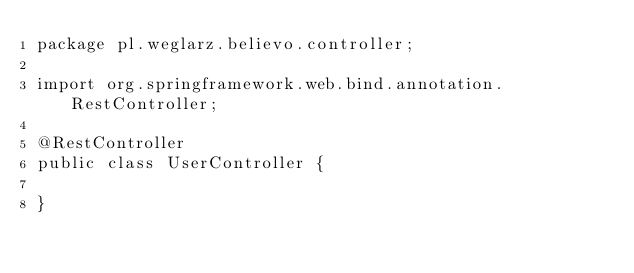<code> <loc_0><loc_0><loc_500><loc_500><_Java_>package pl.weglarz.believo.controller;

import org.springframework.web.bind.annotation.RestController;

@RestController
public class UserController {

}
</code> 